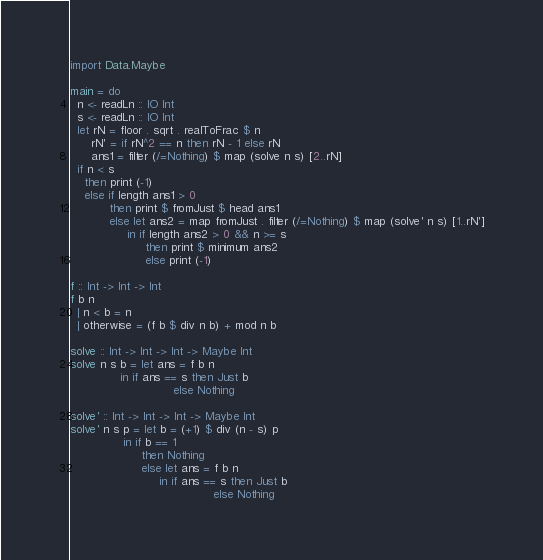Convert code to text. <code><loc_0><loc_0><loc_500><loc_500><_Haskell_>import Data.Maybe

main = do
  n <- readLn :: IO Int
  s <- readLn :: IO Int
  let rN = floor . sqrt . realToFrac $ n
      rN' = if rN^2 == n then rN - 1 else rN
      ans1 = filter (/=Nothing) $ map (solve n s) [2..rN]
  if n < s
    then print (-1)
    else if length ans1 > 0
           then print $ fromJust $ head ans1
           else let ans2 = map fromJust . filter (/=Nothing) $ map (solve' n s) [1..rN']
                in if length ans2 > 0 && n >= s
                     then print $ minimum ans2
                     else print (-1)

f :: Int -> Int -> Int
f b n
  | n < b = n
  | otherwise = (f b $ div n b) + mod n b

solve :: Int -> Int -> Int -> Maybe Int
solve n s b = let ans = f b n
              in if ans == s then Just b
                             else Nothing

solve' :: Int -> Int -> Int -> Maybe Int
solve' n s p = let b = (+1) $ div (n - s) p
               in if b == 1
                    then Nothing
                    else let ans = f b n
                         in if ans == s then Just b
                                        else Nothing
</code> 